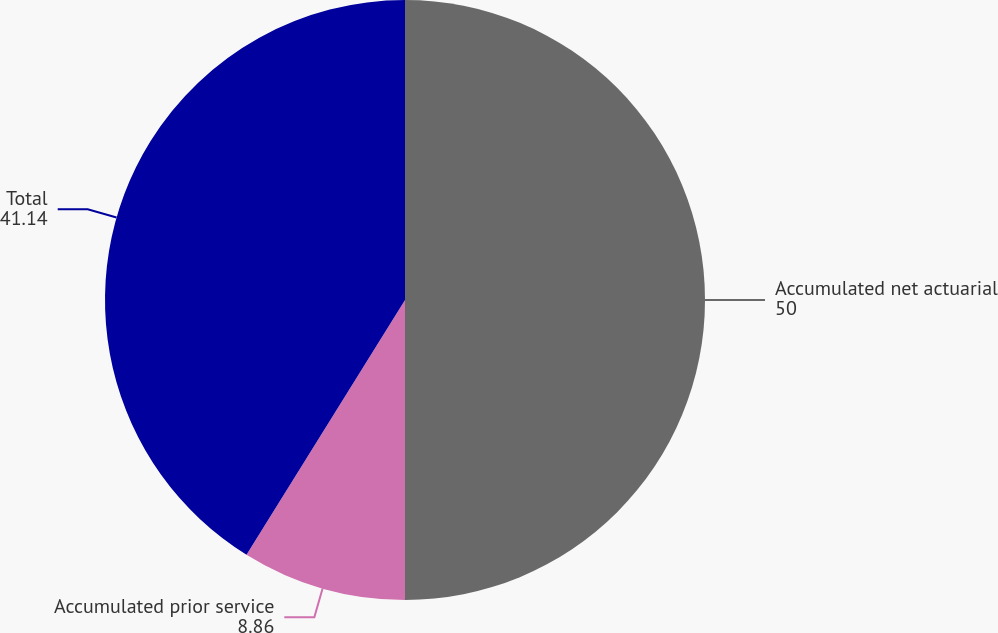<chart> <loc_0><loc_0><loc_500><loc_500><pie_chart><fcel>Accumulated net actuarial<fcel>Accumulated prior service<fcel>Total<nl><fcel>50.0%<fcel>8.86%<fcel>41.14%<nl></chart> 